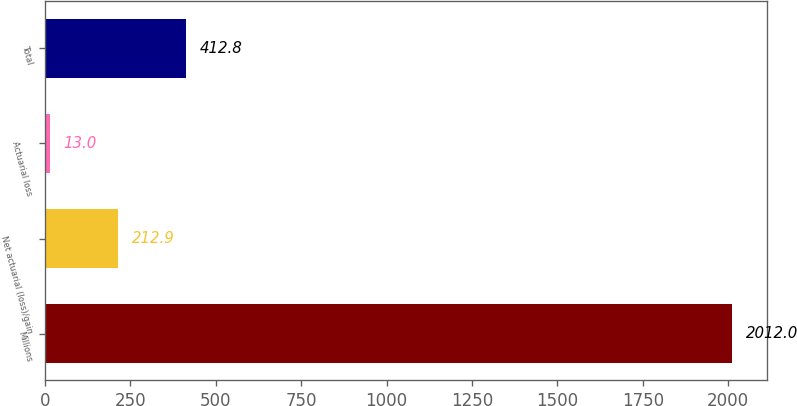<chart> <loc_0><loc_0><loc_500><loc_500><bar_chart><fcel>Millions<fcel>Net actuarial (loss)/gain<fcel>Actuarial loss<fcel>Total<nl><fcel>2012<fcel>212.9<fcel>13<fcel>412.8<nl></chart> 